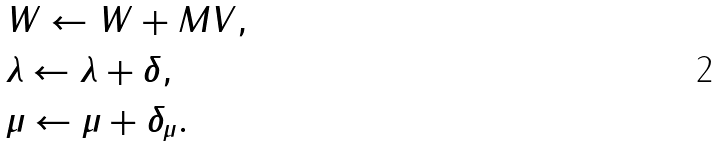Convert formula to latex. <formula><loc_0><loc_0><loc_500><loc_500>& W \gets W + M V , \\ & \lambda \gets \lambda + \delta , \\ & \mu \gets \mu + \delta _ { \mu } .</formula> 